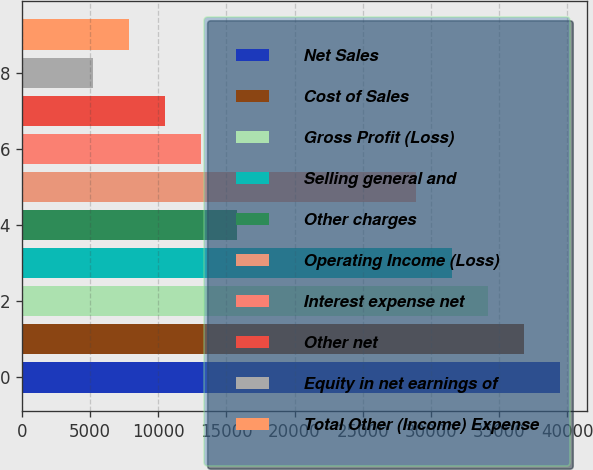Convert chart to OTSL. <chart><loc_0><loc_0><loc_500><loc_500><bar_chart><fcel>Net Sales<fcel>Cost of Sales<fcel>Gross Profit (Loss)<fcel>Selling general and<fcel>Other charges<fcel>Operating Income (Loss)<fcel>Interest expense net<fcel>Other net<fcel>Equity in net earnings of<fcel>Total Other (Income) Expense<nl><fcel>39433.9<fcel>36805.1<fcel>34176.3<fcel>31547.5<fcel>15774.8<fcel>28918.7<fcel>13146.1<fcel>10517.3<fcel>5259.72<fcel>7888.5<nl></chart> 